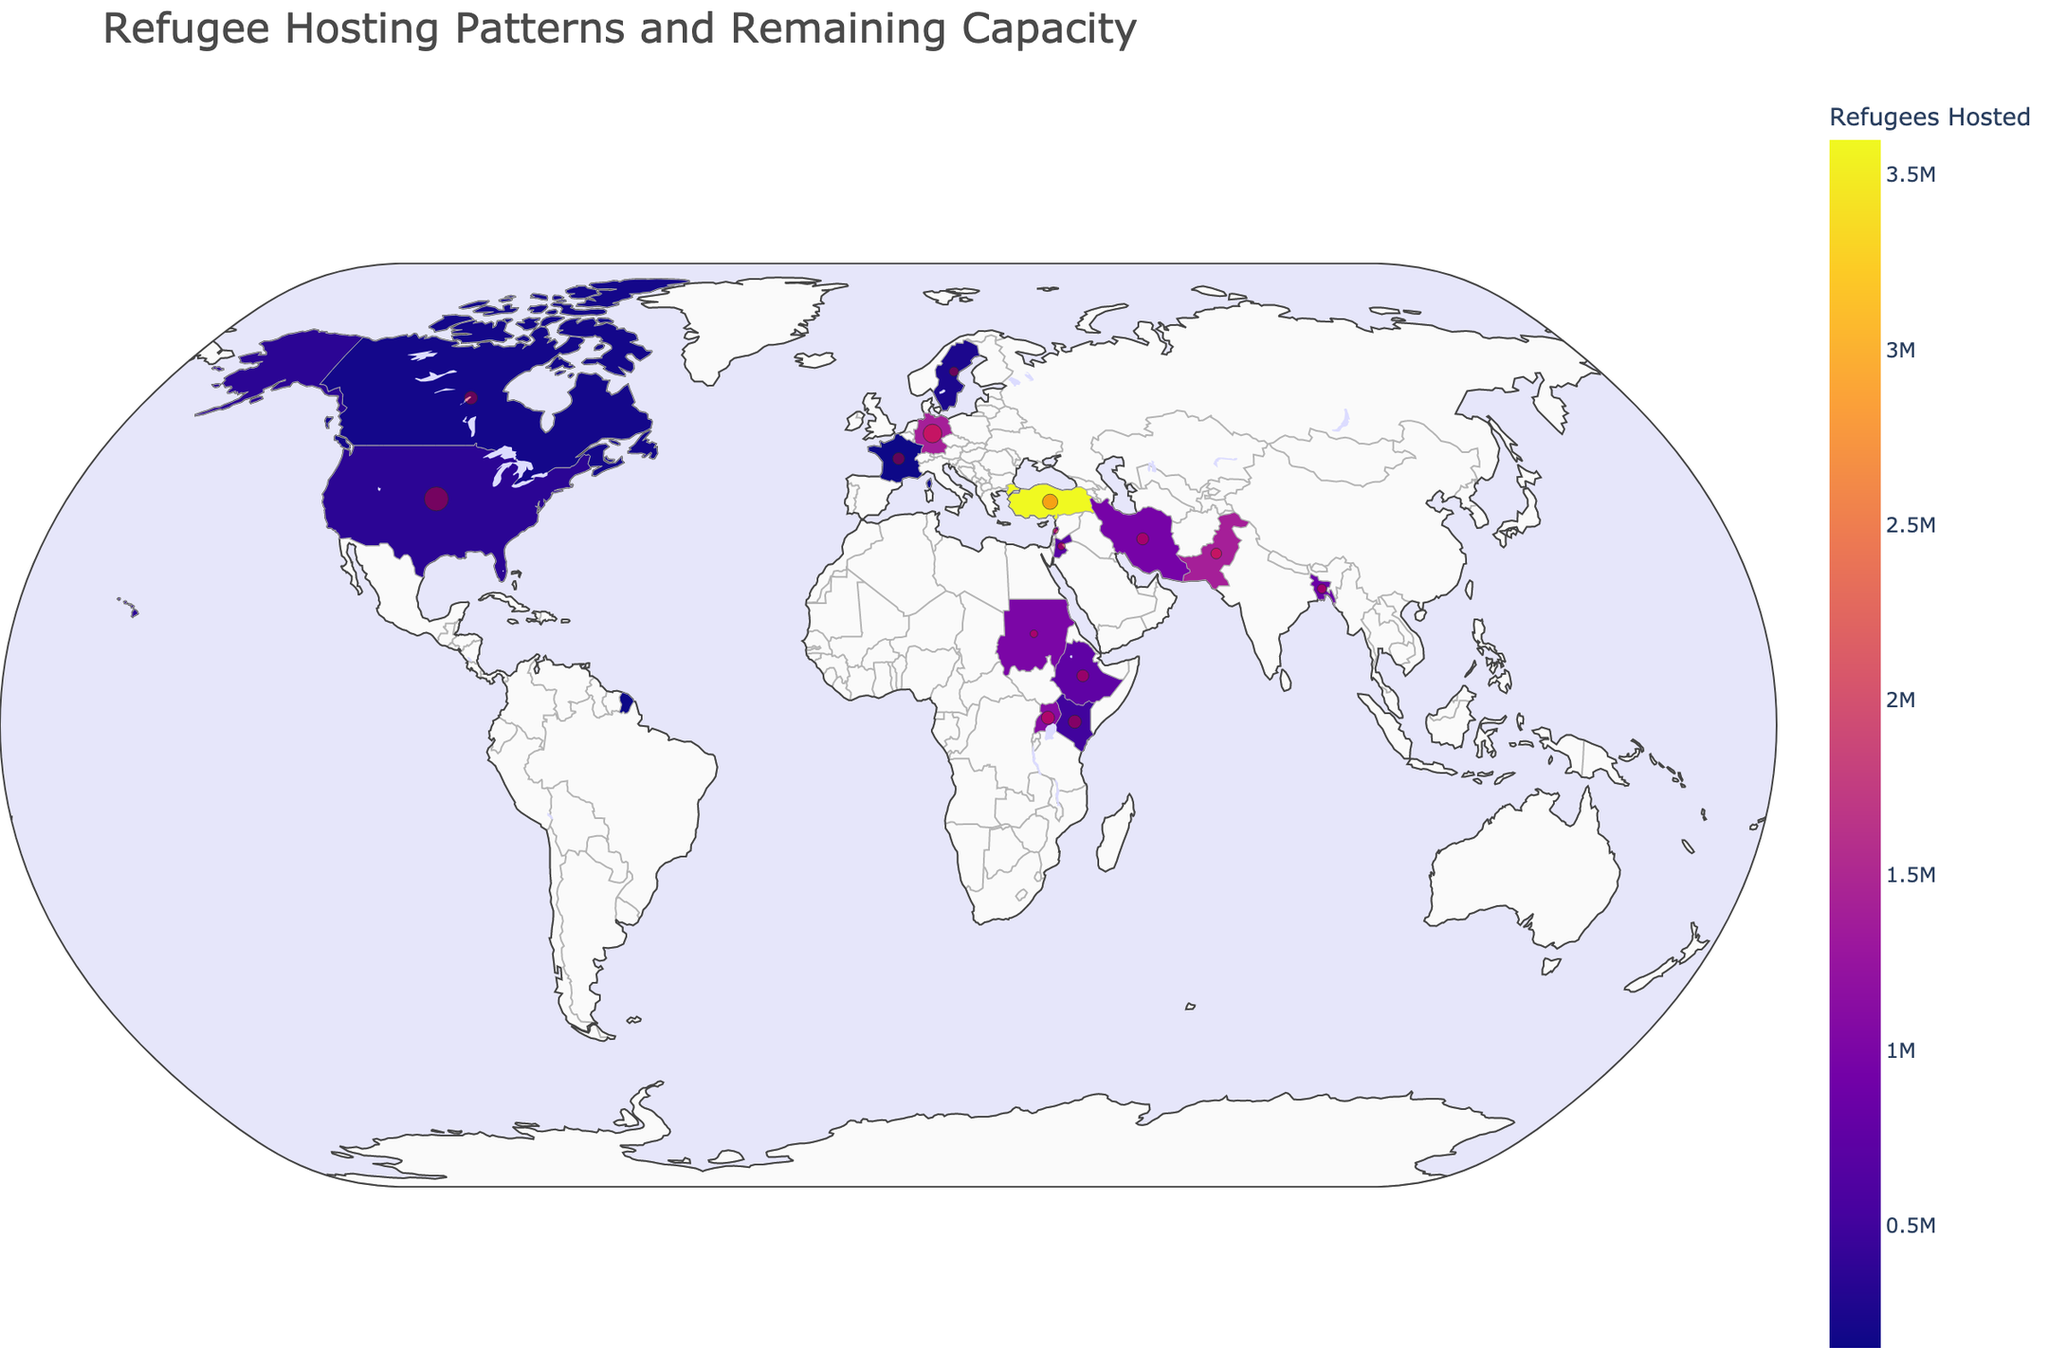Which country hosts the most refugees? The figure highlights refugee hosting data, showing Turkey with the highest refugee population, indicated by the darkest color and the largest vertical bar in the legend.
Answer: Turkey What is the color range used to represent the number of refugees hosted by a country? The color range in the plot, from a pale yellow to a dark purple, represents the gradient of refugee populations hosted by countries. The darker the color, the higher the number of refugees hosted.
Answer: Pale yellow to dark purple How many countries have bilateral agreements listed in the dataset? Review the figure annotations and symbols; several countries are denoted with specific markers indicating bilateral agreements. Counting these markers reveals that 10 countries have such agreements.
Answer: 10 Which country has the highest remaining capacity to host more refugees? The red bubble size on the plot indicates remaining capacities. The United States has the largest bubble, indicating the highest capacity remaining to host more refugees.
Answer: United States Compare the number of refugees hosted by Germany and Pakistan. Which country hosts more? By examining the plot, both countries are shaded to represent their refugee numbers, but Germany has a darker shade (indicative of 1,400,000 refugees). Both host 1,400,000, so they are the same.
Answer: Equal What is the combined remaining capacity of Lebanon and Jordan? Identify the capacity remaining for both Lebanon (50,000) and Jordan (100,000) and sum them up. This gives a combined capacity of 150,000 refugees.
Answer: 150,000 Which two countries hosting refugees from South Sudan have the highest capacities left to serve more refugees? The plot marks three countries hosting South Sudan refugees: Uganda, Sudan, and Ethiopia. Comparing their bubble sizes, Uganda (300,000) and Ethiopia (250,000) have the highest capacities remaining.
Answer: Uganda and Ethiopia How does the hosting capacity of Canada compare to that of Sweden? From the plot, Canada has a larger remaining capacity (300,000) compared to Sweden (150,000), as indicated by bubble sizes.
Answer: Canada > Sweden Explain the relationship between the refuge numbers hosted and the capacities remaining. The figure shows that often, countries hosting large refugee numbers (darker colors) may still have considerable remaining capacity (larger bubbles). However, there is no direct proportional trend as some countries like Turkey have high refugee numbers and still significant remaining capacity, while others like Lebanon have less remaining capacity despite hosting many refugees.
Answer: Varies, not necessarily proportional 